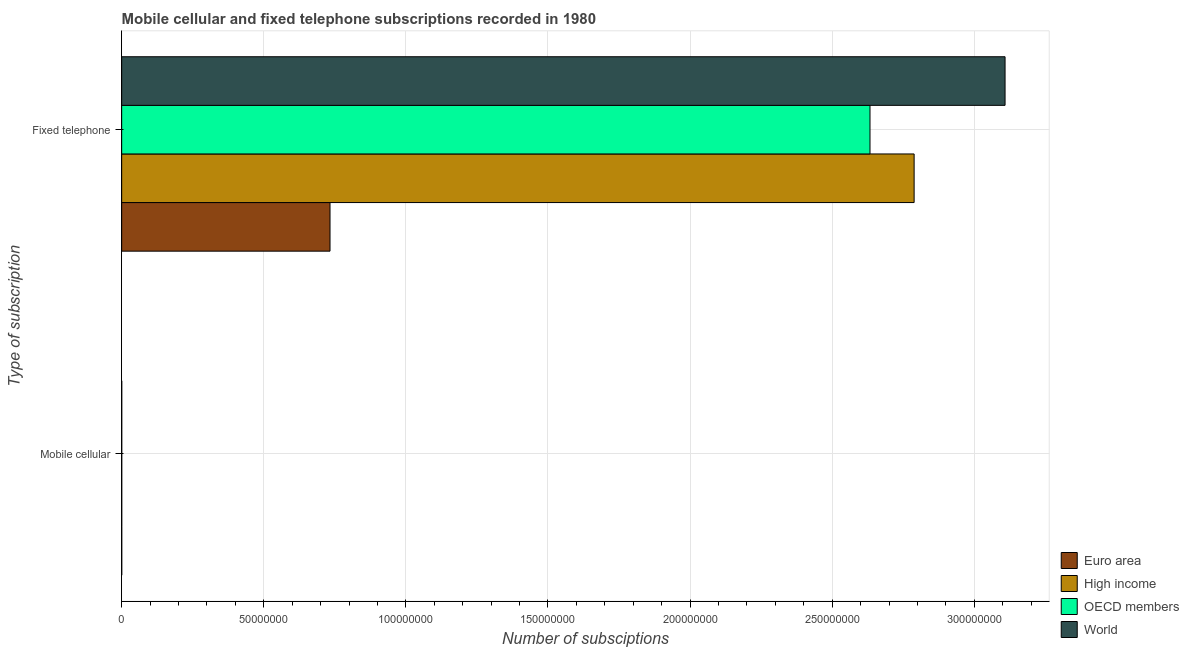Are the number of bars on each tick of the Y-axis equal?
Ensure brevity in your answer.  Yes. How many bars are there on the 2nd tick from the top?
Your answer should be compact. 4. What is the label of the 1st group of bars from the top?
Keep it short and to the point. Fixed telephone. What is the number of fixed telephone subscriptions in High income?
Your answer should be compact. 2.79e+08. Across all countries, what is the maximum number of mobile cellular subscriptions?
Keep it short and to the point. 2.35e+04. Across all countries, what is the minimum number of fixed telephone subscriptions?
Your answer should be compact. 7.33e+07. What is the total number of fixed telephone subscriptions in the graph?
Keep it short and to the point. 9.26e+08. What is the difference between the number of mobile cellular subscriptions in OECD members and the number of fixed telephone subscriptions in High income?
Keep it short and to the point. -2.79e+08. What is the average number of mobile cellular subscriptions per country?
Keep it short and to the point. 2.35e+04. What is the difference between the number of fixed telephone subscriptions and number of mobile cellular subscriptions in OECD members?
Your answer should be compact. 2.63e+08. In how many countries, is the number of fixed telephone subscriptions greater than 70000000 ?
Give a very brief answer. 4. Is the number of fixed telephone subscriptions in Euro area less than that in High income?
Ensure brevity in your answer.  Yes. What does the 1st bar from the bottom in Fixed telephone represents?
Give a very brief answer. Euro area. What is the difference between two consecutive major ticks on the X-axis?
Your answer should be very brief. 5.00e+07. Are the values on the major ticks of X-axis written in scientific E-notation?
Your answer should be very brief. No. Does the graph contain grids?
Ensure brevity in your answer.  Yes. How are the legend labels stacked?
Give a very brief answer. Vertical. What is the title of the graph?
Give a very brief answer. Mobile cellular and fixed telephone subscriptions recorded in 1980. What is the label or title of the X-axis?
Keep it short and to the point. Number of subsciptions. What is the label or title of the Y-axis?
Make the answer very short. Type of subscription. What is the Number of subsciptions of Euro area in Mobile cellular?
Your answer should be compact. 2.35e+04. What is the Number of subsciptions of High income in Mobile cellular?
Offer a very short reply. 2.35e+04. What is the Number of subsciptions of OECD members in Mobile cellular?
Ensure brevity in your answer.  2.35e+04. What is the Number of subsciptions in World in Mobile cellular?
Ensure brevity in your answer.  2.35e+04. What is the Number of subsciptions in Euro area in Fixed telephone?
Offer a terse response. 7.33e+07. What is the Number of subsciptions in High income in Fixed telephone?
Your answer should be compact. 2.79e+08. What is the Number of subsciptions in OECD members in Fixed telephone?
Your response must be concise. 2.63e+08. What is the Number of subsciptions in World in Fixed telephone?
Give a very brief answer. 3.11e+08. Across all Type of subscription, what is the maximum Number of subsciptions in Euro area?
Provide a short and direct response. 7.33e+07. Across all Type of subscription, what is the maximum Number of subsciptions in High income?
Provide a succinct answer. 2.79e+08. Across all Type of subscription, what is the maximum Number of subsciptions in OECD members?
Ensure brevity in your answer.  2.63e+08. Across all Type of subscription, what is the maximum Number of subsciptions of World?
Offer a very short reply. 3.11e+08. Across all Type of subscription, what is the minimum Number of subsciptions in Euro area?
Your answer should be compact. 2.35e+04. Across all Type of subscription, what is the minimum Number of subsciptions in High income?
Your response must be concise. 2.35e+04. Across all Type of subscription, what is the minimum Number of subsciptions in OECD members?
Your response must be concise. 2.35e+04. Across all Type of subscription, what is the minimum Number of subsciptions in World?
Your response must be concise. 2.35e+04. What is the total Number of subsciptions in Euro area in the graph?
Your answer should be compact. 7.33e+07. What is the total Number of subsciptions of High income in the graph?
Your response must be concise. 2.79e+08. What is the total Number of subsciptions of OECD members in the graph?
Your answer should be very brief. 2.63e+08. What is the total Number of subsciptions in World in the graph?
Ensure brevity in your answer.  3.11e+08. What is the difference between the Number of subsciptions in Euro area in Mobile cellular and that in Fixed telephone?
Your answer should be compact. -7.33e+07. What is the difference between the Number of subsciptions of High income in Mobile cellular and that in Fixed telephone?
Ensure brevity in your answer.  -2.79e+08. What is the difference between the Number of subsciptions in OECD members in Mobile cellular and that in Fixed telephone?
Provide a succinct answer. -2.63e+08. What is the difference between the Number of subsciptions in World in Mobile cellular and that in Fixed telephone?
Give a very brief answer. -3.11e+08. What is the difference between the Number of subsciptions in Euro area in Mobile cellular and the Number of subsciptions in High income in Fixed telephone?
Keep it short and to the point. -2.79e+08. What is the difference between the Number of subsciptions of Euro area in Mobile cellular and the Number of subsciptions of OECD members in Fixed telephone?
Offer a very short reply. -2.63e+08. What is the difference between the Number of subsciptions of Euro area in Mobile cellular and the Number of subsciptions of World in Fixed telephone?
Your response must be concise. -3.11e+08. What is the difference between the Number of subsciptions in High income in Mobile cellular and the Number of subsciptions in OECD members in Fixed telephone?
Keep it short and to the point. -2.63e+08. What is the difference between the Number of subsciptions in High income in Mobile cellular and the Number of subsciptions in World in Fixed telephone?
Provide a short and direct response. -3.11e+08. What is the difference between the Number of subsciptions in OECD members in Mobile cellular and the Number of subsciptions in World in Fixed telephone?
Your answer should be compact. -3.11e+08. What is the average Number of subsciptions of Euro area per Type of subscription?
Your answer should be very brief. 3.67e+07. What is the average Number of subsciptions in High income per Type of subscription?
Keep it short and to the point. 1.39e+08. What is the average Number of subsciptions in OECD members per Type of subscription?
Make the answer very short. 1.32e+08. What is the average Number of subsciptions in World per Type of subscription?
Offer a terse response. 1.55e+08. What is the difference between the Number of subsciptions of Euro area and Number of subsciptions of World in Mobile cellular?
Offer a terse response. 0. What is the difference between the Number of subsciptions in High income and Number of subsciptions in World in Mobile cellular?
Your answer should be compact. 0. What is the difference between the Number of subsciptions in OECD members and Number of subsciptions in World in Mobile cellular?
Provide a short and direct response. 0. What is the difference between the Number of subsciptions in Euro area and Number of subsciptions in High income in Fixed telephone?
Ensure brevity in your answer.  -2.06e+08. What is the difference between the Number of subsciptions of Euro area and Number of subsciptions of OECD members in Fixed telephone?
Offer a very short reply. -1.90e+08. What is the difference between the Number of subsciptions of Euro area and Number of subsciptions of World in Fixed telephone?
Keep it short and to the point. -2.38e+08. What is the difference between the Number of subsciptions of High income and Number of subsciptions of OECD members in Fixed telephone?
Give a very brief answer. 1.55e+07. What is the difference between the Number of subsciptions in High income and Number of subsciptions in World in Fixed telephone?
Offer a very short reply. -3.20e+07. What is the difference between the Number of subsciptions of OECD members and Number of subsciptions of World in Fixed telephone?
Keep it short and to the point. -4.75e+07. What is the ratio of the Number of subsciptions in High income in Mobile cellular to that in Fixed telephone?
Keep it short and to the point. 0. What is the ratio of the Number of subsciptions in OECD members in Mobile cellular to that in Fixed telephone?
Offer a very short reply. 0. What is the ratio of the Number of subsciptions of World in Mobile cellular to that in Fixed telephone?
Provide a short and direct response. 0. What is the difference between the highest and the second highest Number of subsciptions in Euro area?
Your response must be concise. 7.33e+07. What is the difference between the highest and the second highest Number of subsciptions in High income?
Make the answer very short. 2.79e+08. What is the difference between the highest and the second highest Number of subsciptions of OECD members?
Ensure brevity in your answer.  2.63e+08. What is the difference between the highest and the second highest Number of subsciptions of World?
Offer a very short reply. 3.11e+08. What is the difference between the highest and the lowest Number of subsciptions of Euro area?
Make the answer very short. 7.33e+07. What is the difference between the highest and the lowest Number of subsciptions of High income?
Offer a terse response. 2.79e+08. What is the difference between the highest and the lowest Number of subsciptions of OECD members?
Your answer should be very brief. 2.63e+08. What is the difference between the highest and the lowest Number of subsciptions in World?
Ensure brevity in your answer.  3.11e+08. 